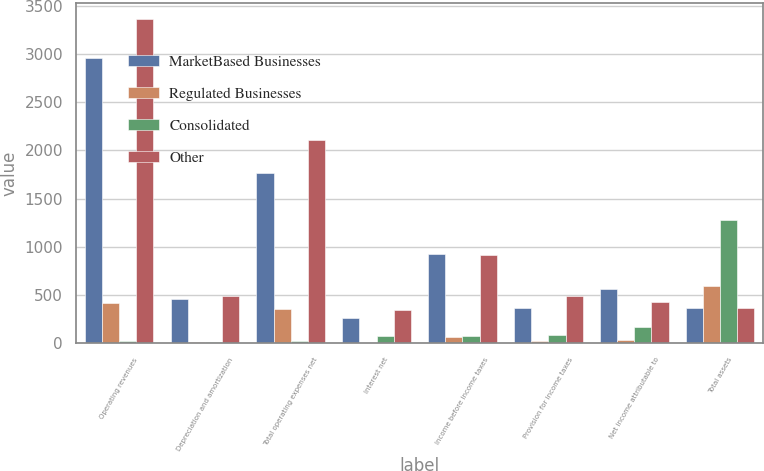Convert chart. <chart><loc_0><loc_0><loc_500><loc_500><stacked_bar_chart><ecel><fcel>Operating revenues<fcel>Depreciation and amortization<fcel>Total operating expenses net<fcel>Interest net<fcel>Income before income taxes<fcel>Provision for income taxes<fcel>Net income attributable to<fcel>Total assets<nl><fcel>MarketBased Businesses<fcel>2958<fcel>462<fcel>1766<fcel>268<fcel>925<fcel>366<fcel>559<fcel>363<nl><fcel>Regulated Businesses<fcel>422<fcel>18<fcel>360<fcel>3<fcel>66<fcel>28<fcel>38<fcel>599<nl><fcel>Consolidated<fcel>23<fcel>12<fcel>22<fcel>77<fcel>79<fcel>92<fcel>171<fcel>1281<nl><fcel>Other<fcel>3357<fcel>492<fcel>2104<fcel>342<fcel>912<fcel>486<fcel>426<fcel>363<nl></chart> 